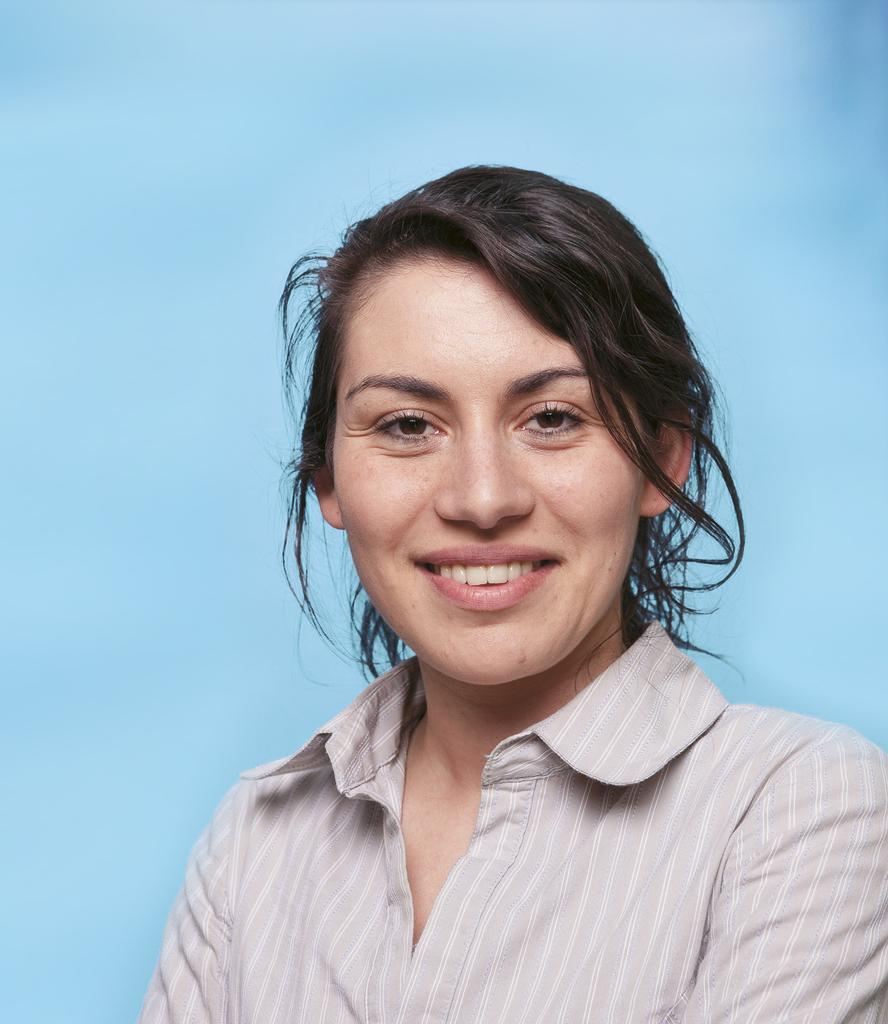Who is in the picture? There is a woman in the picture. What is the woman doing in the picture? The woman is smiling in the picture. What color is the background of the image? The background of the image is blue. What type of wheel can be seen in the picture? There is no wheel present in the picture; it features a woman smiling against a blue background. 